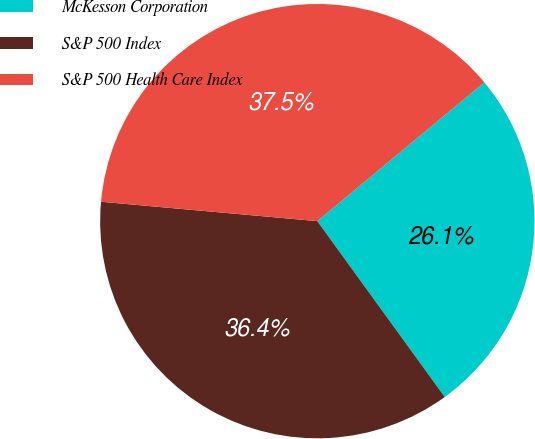Convert chart to OTSL. <chart><loc_0><loc_0><loc_500><loc_500><pie_chart><fcel>McKesson Corporation<fcel>S&P 500 Index<fcel>S&P 500 Health Care Index<nl><fcel>26.05%<fcel>36.4%<fcel>37.54%<nl></chart> 